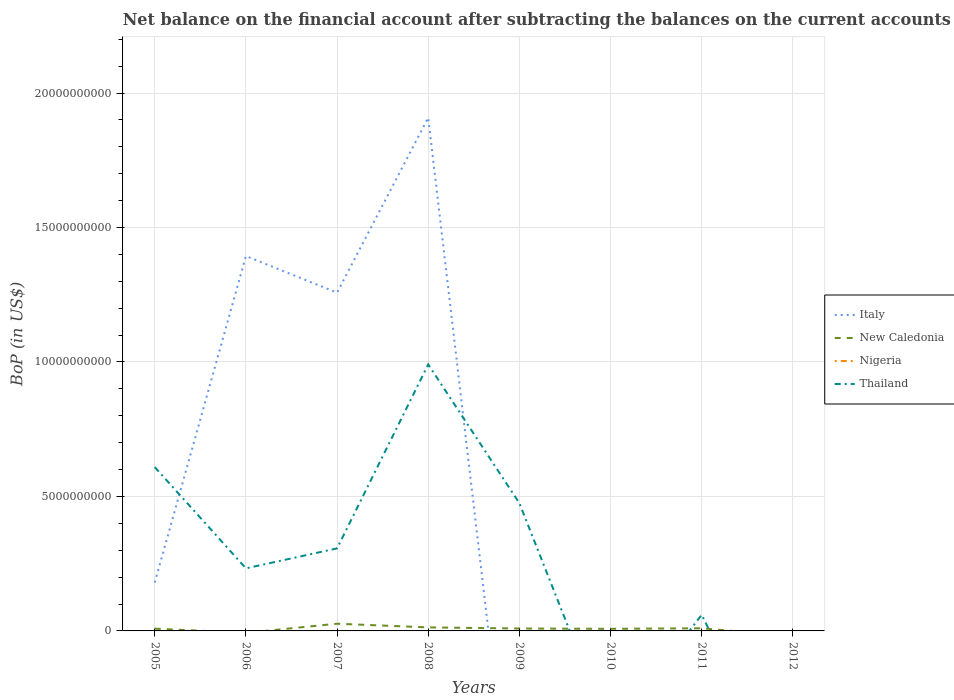How many different coloured lines are there?
Provide a succinct answer. 3. Does the line corresponding to Italy intersect with the line corresponding to Thailand?
Offer a terse response. Yes. Is the number of lines equal to the number of legend labels?
Your answer should be very brief. No. What is the total Balance of Payments in Thailand in the graph?
Make the answer very short. -2.42e+09. What is the difference between the highest and the second highest Balance of Payments in Thailand?
Ensure brevity in your answer.  9.91e+09. What is the difference between the highest and the lowest Balance of Payments in New Caledonia?
Provide a succinct answer. 3. Is the Balance of Payments in Thailand strictly greater than the Balance of Payments in New Caledonia over the years?
Keep it short and to the point. No. How many lines are there?
Your response must be concise. 3. How many years are there in the graph?
Keep it short and to the point. 8. What is the difference between two consecutive major ticks on the Y-axis?
Your answer should be very brief. 5.00e+09. Does the graph contain grids?
Offer a very short reply. Yes. What is the title of the graph?
Provide a succinct answer. Net balance on the financial account after subtracting the balances on the current accounts. Does "Barbados" appear as one of the legend labels in the graph?
Provide a succinct answer. No. What is the label or title of the Y-axis?
Your response must be concise. BoP (in US$). What is the BoP (in US$) of Italy in 2005?
Your answer should be very brief. 1.80e+09. What is the BoP (in US$) of New Caledonia in 2005?
Keep it short and to the point. 8.45e+07. What is the BoP (in US$) of Nigeria in 2005?
Give a very brief answer. 0. What is the BoP (in US$) in Thailand in 2005?
Give a very brief answer. 6.09e+09. What is the BoP (in US$) of Italy in 2006?
Keep it short and to the point. 1.39e+1. What is the BoP (in US$) of New Caledonia in 2006?
Your response must be concise. 0. What is the BoP (in US$) of Nigeria in 2006?
Offer a very short reply. 0. What is the BoP (in US$) of Thailand in 2006?
Your response must be concise. 2.33e+09. What is the BoP (in US$) of Italy in 2007?
Make the answer very short. 1.26e+1. What is the BoP (in US$) of New Caledonia in 2007?
Make the answer very short. 2.68e+08. What is the BoP (in US$) in Thailand in 2007?
Your response must be concise. 3.07e+09. What is the BoP (in US$) of Italy in 2008?
Provide a succinct answer. 1.91e+1. What is the BoP (in US$) of New Caledonia in 2008?
Your response must be concise. 1.31e+08. What is the BoP (in US$) in Thailand in 2008?
Your answer should be compact. 9.91e+09. What is the BoP (in US$) of Italy in 2009?
Your answer should be compact. 0. What is the BoP (in US$) in New Caledonia in 2009?
Provide a succinct answer. 8.96e+07. What is the BoP (in US$) of Thailand in 2009?
Give a very brief answer. 4.75e+09. What is the BoP (in US$) in New Caledonia in 2010?
Offer a very short reply. 7.82e+07. What is the BoP (in US$) of Nigeria in 2010?
Provide a succinct answer. 0. What is the BoP (in US$) of Thailand in 2010?
Provide a short and direct response. 0. What is the BoP (in US$) in New Caledonia in 2011?
Ensure brevity in your answer.  9.86e+07. What is the BoP (in US$) in Nigeria in 2011?
Offer a very short reply. 0. What is the BoP (in US$) of Thailand in 2011?
Your answer should be compact. 6.01e+08. What is the BoP (in US$) in New Caledonia in 2012?
Offer a terse response. 0. What is the BoP (in US$) of Thailand in 2012?
Your answer should be very brief. 0. Across all years, what is the maximum BoP (in US$) of Italy?
Your answer should be compact. 1.91e+1. Across all years, what is the maximum BoP (in US$) in New Caledonia?
Offer a terse response. 2.68e+08. Across all years, what is the maximum BoP (in US$) in Thailand?
Provide a short and direct response. 9.91e+09. Across all years, what is the minimum BoP (in US$) in Italy?
Your response must be concise. 0. Across all years, what is the minimum BoP (in US$) of New Caledonia?
Make the answer very short. 0. What is the total BoP (in US$) in Italy in the graph?
Make the answer very short. 4.74e+1. What is the total BoP (in US$) of New Caledonia in the graph?
Offer a very short reply. 7.50e+08. What is the total BoP (in US$) of Thailand in the graph?
Your answer should be very brief. 2.67e+1. What is the difference between the BoP (in US$) of Italy in 2005 and that in 2006?
Keep it short and to the point. -1.21e+1. What is the difference between the BoP (in US$) in Thailand in 2005 and that in 2006?
Provide a succinct answer. 3.76e+09. What is the difference between the BoP (in US$) in Italy in 2005 and that in 2007?
Your response must be concise. -1.08e+1. What is the difference between the BoP (in US$) in New Caledonia in 2005 and that in 2007?
Offer a terse response. -1.84e+08. What is the difference between the BoP (in US$) of Thailand in 2005 and that in 2007?
Give a very brief answer. 3.02e+09. What is the difference between the BoP (in US$) in Italy in 2005 and that in 2008?
Your answer should be compact. -1.73e+1. What is the difference between the BoP (in US$) of New Caledonia in 2005 and that in 2008?
Your answer should be very brief. -4.66e+07. What is the difference between the BoP (in US$) of Thailand in 2005 and that in 2008?
Your response must be concise. -3.82e+09. What is the difference between the BoP (in US$) of New Caledonia in 2005 and that in 2009?
Your response must be concise. -5.09e+06. What is the difference between the BoP (in US$) of Thailand in 2005 and that in 2009?
Provide a succinct answer. 1.34e+09. What is the difference between the BoP (in US$) in New Caledonia in 2005 and that in 2010?
Provide a short and direct response. 6.35e+06. What is the difference between the BoP (in US$) of New Caledonia in 2005 and that in 2011?
Provide a succinct answer. -1.41e+07. What is the difference between the BoP (in US$) of Thailand in 2005 and that in 2011?
Provide a short and direct response. 5.49e+09. What is the difference between the BoP (in US$) of Italy in 2006 and that in 2007?
Offer a very short reply. 1.36e+09. What is the difference between the BoP (in US$) of Thailand in 2006 and that in 2007?
Ensure brevity in your answer.  -7.42e+08. What is the difference between the BoP (in US$) in Italy in 2006 and that in 2008?
Ensure brevity in your answer.  -5.15e+09. What is the difference between the BoP (in US$) in Thailand in 2006 and that in 2008?
Keep it short and to the point. -7.58e+09. What is the difference between the BoP (in US$) in Thailand in 2006 and that in 2009?
Make the answer very short. -2.42e+09. What is the difference between the BoP (in US$) in Thailand in 2006 and that in 2011?
Your answer should be very brief. 1.73e+09. What is the difference between the BoP (in US$) of Italy in 2007 and that in 2008?
Make the answer very short. -6.51e+09. What is the difference between the BoP (in US$) in New Caledonia in 2007 and that in 2008?
Provide a succinct answer. 1.37e+08. What is the difference between the BoP (in US$) of Thailand in 2007 and that in 2008?
Ensure brevity in your answer.  -6.84e+09. What is the difference between the BoP (in US$) of New Caledonia in 2007 and that in 2009?
Provide a short and direct response. 1.79e+08. What is the difference between the BoP (in US$) in Thailand in 2007 and that in 2009?
Your response must be concise. -1.68e+09. What is the difference between the BoP (in US$) in New Caledonia in 2007 and that in 2010?
Your answer should be compact. 1.90e+08. What is the difference between the BoP (in US$) in New Caledonia in 2007 and that in 2011?
Offer a terse response. 1.70e+08. What is the difference between the BoP (in US$) of Thailand in 2007 and that in 2011?
Your response must be concise. 2.47e+09. What is the difference between the BoP (in US$) of New Caledonia in 2008 and that in 2009?
Your response must be concise. 4.15e+07. What is the difference between the BoP (in US$) of Thailand in 2008 and that in 2009?
Give a very brief answer. 5.16e+09. What is the difference between the BoP (in US$) in New Caledonia in 2008 and that in 2010?
Offer a terse response. 5.30e+07. What is the difference between the BoP (in US$) of New Caledonia in 2008 and that in 2011?
Give a very brief answer. 3.26e+07. What is the difference between the BoP (in US$) in Thailand in 2008 and that in 2011?
Your answer should be very brief. 9.31e+09. What is the difference between the BoP (in US$) in New Caledonia in 2009 and that in 2010?
Make the answer very short. 1.14e+07. What is the difference between the BoP (in US$) of New Caledonia in 2009 and that in 2011?
Keep it short and to the point. -8.97e+06. What is the difference between the BoP (in US$) in Thailand in 2009 and that in 2011?
Your response must be concise. 4.15e+09. What is the difference between the BoP (in US$) of New Caledonia in 2010 and that in 2011?
Keep it short and to the point. -2.04e+07. What is the difference between the BoP (in US$) in Italy in 2005 and the BoP (in US$) in Thailand in 2006?
Your response must be concise. -5.28e+08. What is the difference between the BoP (in US$) of New Caledonia in 2005 and the BoP (in US$) of Thailand in 2006?
Offer a terse response. -2.24e+09. What is the difference between the BoP (in US$) in Italy in 2005 and the BoP (in US$) in New Caledonia in 2007?
Your response must be concise. 1.53e+09. What is the difference between the BoP (in US$) of Italy in 2005 and the BoP (in US$) of Thailand in 2007?
Your response must be concise. -1.27e+09. What is the difference between the BoP (in US$) of New Caledonia in 2005 and the BoP (in US$) of Thailand in 2007?
Offer a terse response. -2.98e+09. What is the difference between the BoP (in US$) of Italy in 2005 and the BoP (in US$) of New Caledonia in 2008?
Provide a succinct answer. 1.67e+09. What is the difference between the BoP (in US$) of Italy in 2005 and the BoP (in US$) of Thailand in 2008?
Give a very brief answer. -8.11e+09. What is the difference between the BoP (in US$) of New Caledonia in 2005 and the BoP (in US$) of Thailand in 2008?
Provide a short and direct response. -9.82e+09. What is the difference between the BoP (in US$) in Italy in 2005 and the BoP (in US$) in New Caledonia in 2009?
Your response must be concise. 1.71e+09. What is the difference between the BoP (in US$) of Italy in 2005 and the BoP (in US$) of Thailand in 2009?
Provide a short and direct response. -2.95e+09. What is the difference between the BoP (in US$) in New Caledonia in 2005 and the BoP (in US$) in Thailand in 2009?
Offer a terse response. -4.67e+09. What is the difference between the BoP (in US$) of Italy in 2005 and the BoP (in US$) of New Caledonia in 2010?
Keep it short and to the point. 1.72e+09. What is the difference between the BoP (in US$) of Italy in 2005 and the BoP (in US$) of New Caledonia in 2011?
Provide a short and direct response. 1.70e+09. What is the difference between the BoP (in US$) of Italy in 2005 and the BoP (in US$) of Thailand in 2011?
Your answer should be very brief. 1.20e+09. What is the difference between the BoP (in US$) in New Caledonia in 2005 and the BoP (in US$) in Thailand in 2011?
Your response must be concise. -5.16e+08. What is the difference between the BoP (in US$) in Italy in 2006 and the BoP (in US$) in New Caledonia in 2007?
Give a very brief answer. 1.37e+1. What is the difference between the BoP (in US$) in Italy in 2006 and the BoP (in US$) in Thailand in 2007?
Provide a short and direct response. 1.09e+1. What is the difference between the BoP (in US$) in Italy in 2006 and the BoP (in US$) in New Caledonia in 2008?
Your response must be concise. 1.38e+1. What is the difference between the BoP (in US$) of Italy in 2006 and the BoP (in US$) of Thailand in 2008?
Your answer should be compact. 4.03e+09. What is the difference between the BoP (in US$) of Italy in 2006 and the BoP (in US$) of New Caledonia in 2009?
Keep it short and to the point. 1.38e+1. What is the difference between the BoP (in US$) in Italy in 2006 and the BoP (in US$) in Thailand in 2009?
Give a very brief answer. 9.19e+09. What is the difference between the BoP (in US$) in Italy in 2006 and the BoP (in US$) in New Caledonia in 2010?
Make the answer very short. 1.39e+1. What is the difference between the BoP (in US$) in Italy in 2006 and the BoP (in US$) in New Caledonia in 2011?
Offer a terse response. 1.38e+1. What is the difference between the BoP (in US$) in Italy in 2006 and the BoP (in US$) in Thailand in 2011?
Provide a short and direct response. 1.33e+1. What is the difference between the BoP (in US$) in Italy in 2007 and the BoP (in US$) in New Caledonia in 2008?
Your answer should be very brief. 1.24e+1. What is the difference between the BoP (in US$) of Italy in 2007 and the BoP (in US$) of Thailand in 2008?
Your answer should be compact. 2.67e+09. What is the difference between the BoP (in US$) of New Caledonia in 2007 and the BoP (in US$) of Thailand in 2008?
Give a very brief answer. -9.64e+09. What is the difference between the BoP (in US$) in Italy in 2007 and the BoP (in US$) in New Caledonia in 2009?
Your response must be concise. 1.25e+1. What is the difference between the BoP (in US$) in Italy in 2007 and the BoP (in US$) in Thailand in 2009?
Provide a short and direct response. 7.83e+09. What is the difference between the BoP (in US$) of New Caledonia in 2007 and the BoP (in US$) of Thailand in 2009?
Make the answer very short. -4.48e+09. What is the difference between the BoP (in US$) of Italy in 2007 and the BoP (in US$) of New Caledonia in 2010?
Keep it short and to the point. 1.25e+1. What is the difference between the BoP (in US$) of Italy in 2007 and the BoP (in US$) of New Caledonia in 2011?
Provide a short and direct response. 1.25e+1. What is the difference between the BoP (in US$) of Italy in 2007 and the BoP (in US$) of Thailand in 2011?
Provide a succinct answer. 1.20e+1. What is the difference between the BoP (in US$) of New Caledonia in 2007 and the BoP (in US$) of Thailand in 2011?
Keep it short and to the point. -3.32e+08. What is the difference between the BoP (in US$) in Italy in 2008 and the BoP (in US$) in New Caledonia in 2009?
Make the answer very short. 1.90e+1. What is the difference between the BoP (in US$) in Italy in 2008 and the BoP (in US$) in Thailand in 2009?
Ensure brevity in your answer.  1.43e+1. What is the difference between the BoP (in US$) in New Caledonia in 2008 and the BoP (in US$) in Thailand in 2009?
Offer a very short reply. -4.62e+09. What is the difference between the BoP (in US$) of Italy in 2008 and the BoP (in US$) of New Caledonia in 2010?
Offer a very short reply. 1.90e+1. What is the difference between the BoP (in US$) in Italy in 2008 and the BoP (in US$) in New Caledonia in 2011?
Offer a very short reply. 1.90e+1. What is the difference between the BoP (in US$) of Italy in 2008 and the BoP (in US$) of Thailand in 2011?
Give a very brief answer. 1.85e+1. What is the difference between the BoP (in US$) of New Caledonia in 2008 and the BoP (in US$) of Thailand in 2011?
Offer a very short reply. -4.69e+08. What is the difference between the BoP (in US$) of New Caledonia in 2009 and the BoP (in US$) of Thailand in 2011?
Offer a terse response. -5.11e+08. What is the difference between the BoP (in US$) of New Caledonia in 2010 and the BoP (in US$) of Thailand in 2011?
Give a very brief answer. -5.22e+08. What is the average BoP (in US$) of Italy per year?
Ensure brevity in your answer.  5.93e+09. What is the average BoP (in US$) in New Caledonia per year?
Provide a short and direct response. 9.38e+07. What is the average BoP (in US$) of Nigeria per year?
Provide a short and direct response. 0. What is the average BoP (in US$) of Thailand per year?
Make the answer very short. 3.34e+09. In the year 2005, what is the difference between the BoP (in US$) of Italy and BoP (in US$) of New Caledonia?
Provide a short and direct response. 1.71e+09. In the year 2005, what is the difference between the BoP (in US$) of Italy and BoP (in US$) of Thailand?
Offer a terse response. -4.29e+09. In the year 2005, what is the difference between the BoP (in US$) of New Caledonia and BoP (in US$) of Thailand?
Provide a succinct answer. -6.01e+09. In the year 2006, what is the difference between the BoP (in US$) of Italy and BoP (in US$) of Thailand?
Keep it short and to the point. 1.16e+1. In the year 2007, what is the difference between the BoP (in US$) in Italy and BoP (in US$) in New Caledonia?
Offer a terse response. 1.23e+1. In the year 2007, what is the difference between the BoP (in US$) of Italy and BoP (in US$) of Thailand?
Offer a very short reply. 9.51e+09. In the year 2007, what is the difference between the BoP (in US$) in New Caledonia and BoP (in US$) in Thailand?
Offer a terse response. -2.80e+09. In the year 2008, what is the difference between the BoP (in US$) of Italy and BoP (in US$) of New Caledonia?
Your response must be concise. 1.90e+1. In the year 2008, what is the difference between the BoP (in US$) in Italy and BoP (in US$) in Thailand?
Your answer should be compact. 9.18e+09. In the year 2008, what is the difference between the BoP (in US$) in New Caledonia and BoP (in US$) in Thailand?
Offer a terse response. -9.78e+09. In the year 2009, what is the difference between the BoP (in US$) in New Caledonia and BoP (in US$) in Thailand?
Keep it short and to the point. -4.66e+09. In the year 2011, what is the difference between the BoP (in US$) in New Caledonia and BoP (in US$) in Thailand?
Keep it short and to the point. -5.02e+08. What is the ratio of the BoP (in US$) of Italy in 2005 to that in 2006?
Your answer should be compact. 0.13. What is the ratio of the BoP (in US$) in Thailand in 2005 to that in 2006?
Your answer should be very brief. 2.62. What is the ratio of the BoP (in US$) in Italy in 2005 to that in 2007?
Your answer should be compact. 0.14. What is the ratio of the BoP (in US$) in New Caledonia in 2005 to that in 2007?
Your answer should be compact. 0.32. What is the ratio of the BoP (in US$) of Thailand in 2005 to that in 2007?
Your answer should be compact. 1.98. What is the ratio of the BoP (in US$) of Italy in 2005 to that in 2008?
Provide a short and direct response. 0.09. What is the ratio of the BoP (in US$) of New Caledonia in 2005 to that in 2008?
Your answer should be compact. 0.64. What is the ratio of the BoP (in US$) of Thailand in 2005 to that in 2008?
Offer a very short reply. 0.61. What is the ratio of the BoP (in US$) of New Caledonia in 2005 to that in 2009?
Give a very brief answer. 0.94. What is the ratio of the BoP (in US$) in Thailand in 2005 to that in 2009?
Ensure brevity in your answer.  1.28. What is the ratio of the BoP (in US$) of New Caledonia in 2005 to that in 2010?
Offer a terse response. 1.08. What is the ratio of the BoP (in US$) in New Caledonia in 2005 to that in 2011?
Give a very brief answer. 0.86. What is the ratio of the BoP (in US$) in Thailand in 2005 to that in 2011?
Your answer should be very brief. 10.14. What is the ratio of the BoP (in US$) of Italy in 2006 to that in 2007?
Make the answer very short. 1.11. What is the ratio of the BoP (in US$) of Thailand in 2006 to that in 2007?
Offer a terse response. 0.76. What is the ratio of the BoP (in US$) of Italy in 2006 to that in 2008?
Provide a succinct answer. 0.73. What is the ratio of the BoP (in US$) of Thailand in 2006 to that in 2008?
Your answer should be very brief. 0.23. What is the ratio of the BoP (in US$) of Thailand in 2006 to that in 2009?
Ensure brevity in your answer.  0.49. What is the ratio of the BoP (in US$) of Thailand in 2006 to that in 2011?
Your answer should be compact. 3.87. What is the ratio of the BoP (in US$) in Italy in 2007 to that in 2008?
Ensure brevity in your answer.  0.66. What is the ratio of the BoP (in US$) of New Caledonia in 2007 to that in 2008?
Give a very brief answer. 2.04. What is the ratio of the BoP (in US$) of Thailand in 2007 to that in 2008?
Give a very brief answer. 0.31. What is the ratio of the BoP (in US$) in New Caledonia in 2007 to that in 2009?
Provide a succinct answer. 2.99. What is the ratio of the BoP (in US$) of Thailand in 2007 to that in 2009?
Give a very brief answer. 0.65. What is the ratio of the BoP (in US$) in New Caledonia in 2007 to that in 2010?
Offer a terse response. 3.43. What is the ratio of the BoP (in US$) in New Caledonia in 2007 to that in 2011?
Provide a succinct answer. 2.72. What is the ratio of the BoP (in US$) of Thailand in 2007 to that in 2011?
Your answer should be compact. 5.11. What is the ratio of the BoP (in US$) of New Caledonia in 2008 to that in 2009?
Your answer should be very brief. 1.46. What is the ratio of the BoP (in US$) of Thailand in 2008 to that in 2009?
Ensure brevity in your answer.  2.09. What is the ratio of the BoP (in US$) in New Caledonia in 2008 to that in 2010?
Ensure brevity in your answer.  1.68. What is the ratio of the BoP (in US$) of New Caledonia in 2008 to that in 2011?
Give a very brief answer. 1.33. What is the ratio of the BoP (in US$) in Thailand in 2008 to that in 2011?
Provide a succinct answer. 16.5. What is the ratio of the BoP (in US$) in New Caledonia in 2009 to that in 2010?
Give a very brief answer. 1.15. What is the ratio of the BoP (in US$) of New Caledonia in 2009 to that in 2011?
Make the answer very short. 0.91. What is the ratio of the BoP (in US$) in Thailand in 2009 to that in 2011?
Your answer should be very brief. 7.91. What is the ratio of the BoP (in US$) in New Caledonia in 2010 to that in 2011?
Keep it short and to the point. 0.79. What is the difference between the highest and the second highest BoP (in US$) in Italy?
Ensure brevity in your answer.  5.15e+09. What is the difference between the highest and the second highest BoP (in US$) in New Caledonia?
Your response must be concise. 1.37e+08. What is the difference between the highest and the second highest BoP (in US$) in Thailand?
Offer a very short reply. 3.82e+09. What is the difference between the highest and the lowest BoP (in US$) of Italy?
Keep it short and to the point. 1.91e+1. What is the difference between the highest and the lowest BoP (in US$) in New Caledonia?
Keep it short and to the point. 2.68e+08. What is the difference between the highest and the lowest BoP (in US$) of Thailand?
Give a very brief answer. 9.91e+09. 